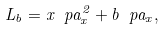Convert formula to latex. <formula><loc_0><loc_0><loc_500><loc_500>L _ { b } = x \ p a _ { x } ^ { 2 } + b \ p a _ { x } ,</formula> 